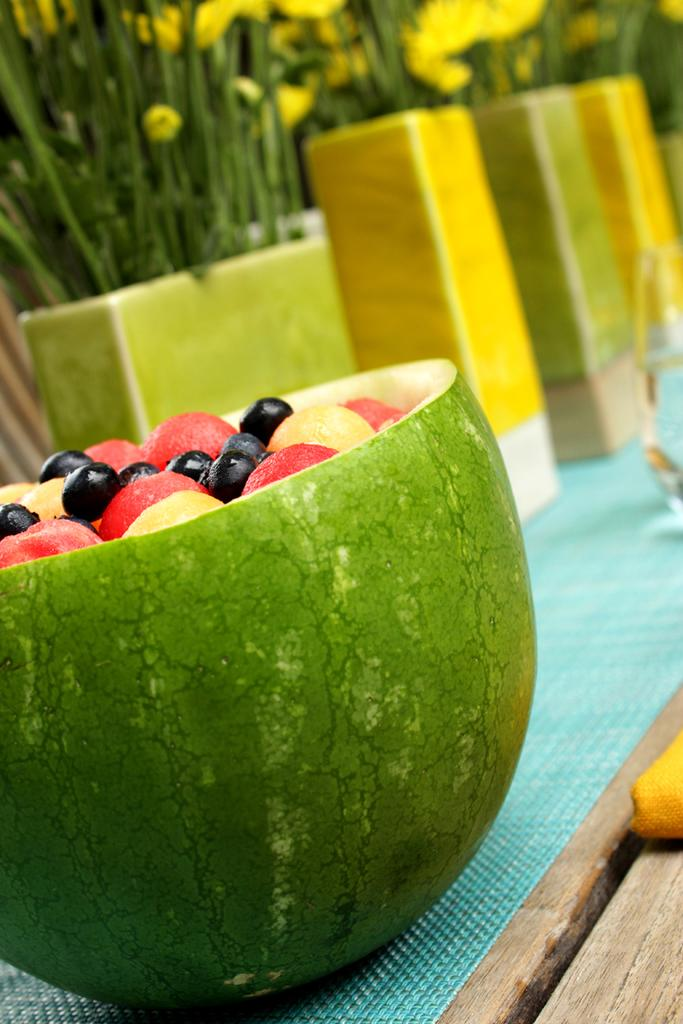What type of table is in the image? There is a wooden table in the image. What is covering the table? There is a cloth on the table. What can be seen on top of the cloth? There are house plants and fruits on the table. What type of rhythm can be heard coming from the desk in the image? There is no desk present in the image, and therefore no rhythm can be heard. 